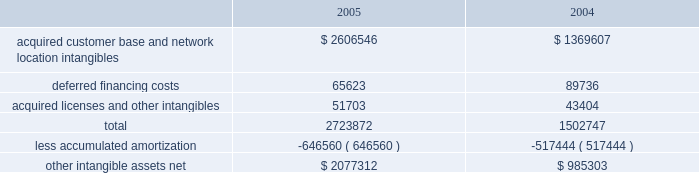American tower corporation and subsidiaries notes to consolidated financial statements 2014 ( continued ) the company has selected december 1 as the date to perform its annual impairment test .
In performing its 2005 and 2004 testing , the company completed an internal appraisal and estimated the fair value of the rental and management reporting unit that contains goodwill utilizing future discounted cash flows and market information .
Based on the appraisals performed , the company determined that goodwill in its rental and management segment was not impaired .
The company 2019s other intangible assets subject to amortization consist of the following as of december 31 , ( in thousands ) : .
The company amortizes its intangible assets over periods ranging from three to fifteen years .
Amortization of intangible assets for the years ended december 31 , 2005 and 2004 aggregated approximately $ 136.0 million and $ 97.8 million , respectively ( excluding amortization of deferred financing costs , which is included in interest expense ) .
The company expects to record amortization expense of approximately $ 183.6 million , $ 178.3 million , $ 174.4 million , $ 172.7 million and $ 170.3 million , for the years ended december 31 , 2006 , 2007 , 2008 , 2009 and 2010 , respectively .
These amounts are subject to changes in estimates until the preliminary allocation of the spectrasite purchase price is finalized .
Notes receivable in 2000 , the company loaned tv azteca , s.a .
De c.v .
( tv azteca ) , the owner of a major national television network in mexico , $ 119.8 million .
The loan , which initially bore interest at 12.87% ( 12.87 % ) , payable quarterly , was discounted by the company , as the fair value interest rate at the date of the loan was determined to be 14.25% ( 14.25 % ) .
The loan was amended effective january 1 , 2003 to increase the original interest rate to 13.11% ( 13.11 % ) .
As of december 31 , 2005 and 2004 , approximately $ 119.8 million undiscounted ( $ 108.2 million discounted ) under the loan was outstanding and included in notes receivable and other long-term assets in the accompanying consolidated balance sheets .
The term of the loan is seventy years ; however , the loan may be prepaid by tv azteca without penalty during the last fifty years of the agreement .
The discount on the loan is being amortized to interest income 2014tv azteca , net , using the effective interest method over the seventy-year term of the loan .
Simultaneous with the signing of the loan agreement , the company also entered into a seventy year economic rights agreement with tv azteca regarding space not used by tv azteca on approximately 190 of its broadcast towers .
In exchange for the issuance of the below market interest rate loan discussed above and the annual payment of $ 1.5 million to tv azteca ( under the economic rights agreement ) , the company has the right to market and lease the unused tower space on the broadcast towers ( the economic rights ) .
Tv azteca retains title to these towers and is responsible for their operation and maintenance .
The company is entitled to 100% ( 100 % ) of the revenues generated from leases with tenants on the unused space and is responsible for any incremental operating expenses associated with those tenants. .
What was the percentage of the increase in the customer intangible asset from 2004 to 2005? 
Computations: ((2723872 - 1502747) / 1502747)
Answer: 0.8126. 